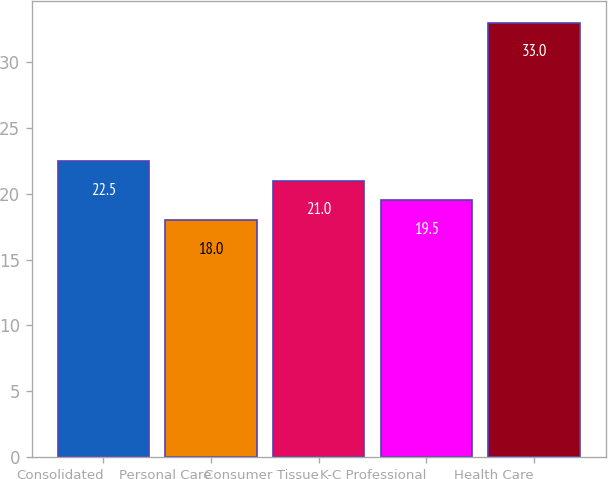Convert chart to OTSL. <chart><loc_0><loc_0><loc_500><loc_500><bar_chart><fcel>Consolidated<fcel>Personal Care<fcel>Consumer Tissue<fcel>K-C Professional<fcel>Health Care<nl><fcel>22.5<fcel>18<fcel>21<fcel>19.5<fcel>33<nl></chart> 